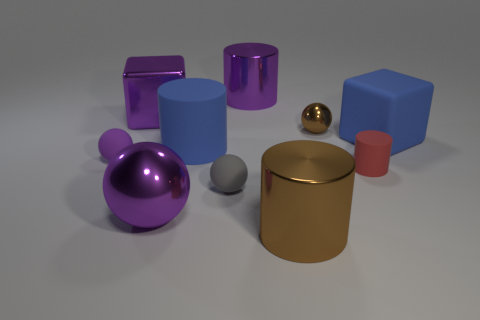Subtract all brown shiny balls. How many balls are left? 3 Subtract all balls. How many objects are left? 6 Subtract all purple blocks. How many blocks are left? 1 Add 3 big rubber cubes. How many big rubber cubes exist? 4 Subtract 1 brown spheres. How many objects are left? 9 Subtract 1 blocks. How many blocks are left? 1 Subtract all red cylinders. Subtract all yellow spheres. How many cylinders are left? 3 Subtract all yellow cylinders. How many blue cubes are left? 1 Subtract all rubber cylinders. Subtract all yellow objects. How many objects are left? 8 Add 9 gray things. How many gray things are left? 10 